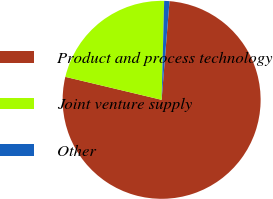Convert chart to OTSL. <chart><loc_0><loc_0><loc_500><loc_500><pie_chart><fcel>Product and process technology<fcel>Joint venture supply<fcel>Other<nl><fcel>77.46%<fcel>21.68%<fcel>0.86%<nl></chart> 